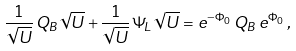Convert formula to latex. <formula><loc_0><loc_0><loc_500><loc_500>\frac { 1 } { \sqrt { U } } \, Q _ { B } \sqrt { U } + \frac { 1 } { \sqrt { U } } \, \Psi _ { L } \, \sqrt { U } = e ^ { - \Phi _ { 0 } } \, Q _ { B } \, e ^ { \Phi _ { 0 } } \, ,</formula> 